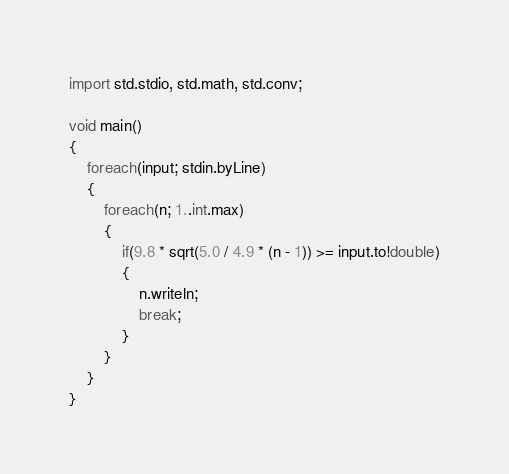<code> <loc_0><loc_0><loc_500><loc_500><_D_>import std.stdio, std.math, std.conv;

void main()
{
    foreach(input; stdin.byLine)
    {
        foreach(n; 1..int.max)
        {
            if(9.8 * sqrt(5.0 / 4.9 * (n - 1)) >= input.to!double)
            {
                n.writeln;
                break;
            }
        }
    }
}</code> 